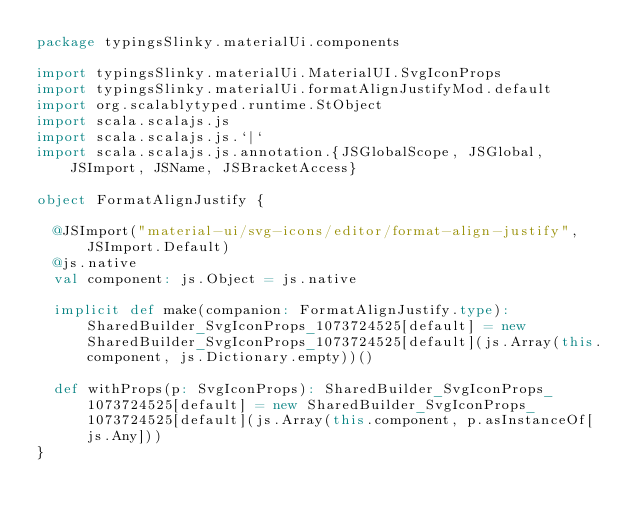Convert code to text. <code><loc_0><loc_0><loc_500><loc_500><_Scala_>package typingsSlinky.materialUi.components

import typingsSlinky.materialUi.MaterialUI.SvgIconProps
import typingsSlinky.materialUi.formatAlignJustifyMod.default
import org.scalablytyped.runtime.StObject
import scala.scalajs.js
import scala.scalajs.js.`|`
import scala.scalajs.js.annotation.{JSGlobalScope, JSGlobal, JSImport, JSName, JSBracketAccess}

object FormatAlignJustify {
  
  @JSImport("material-ui/svg-icons/editor/format-align-justify", JSImport.Default)
  @js.native
  val component: js.Object = js.native
  
  implicit def make(companion: FormatAlignJustify.type): SharedBuilder_SvgIconProps_1073724525[default] = new SharedBuilder_SvgIconProps_1073724525[default](js.Array(this.component, js.Dictionary.empty))()
  
  def withProps(p: SvgIconProps): SharedBuilder_SvgIconProps_1073724525[default] = new SharedBuilder_SvgIconProps_1073724525[default](js.Array(this.component, p.asInstanceOf[js.Any]))
}
</code> 